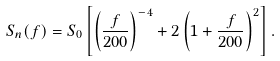<formula> <loc_0><loc_0><loc_500><loc_500>S _ { n } ( f ) = S _ { 0 } \left [ \left ( \frac { f } { 2 0 0 } \right ) ^ { - 4 } + 2 \left ( 1 + \frac { f } { 2 0 0 } \right ) ^ { 2 } \right ] .</formula> 